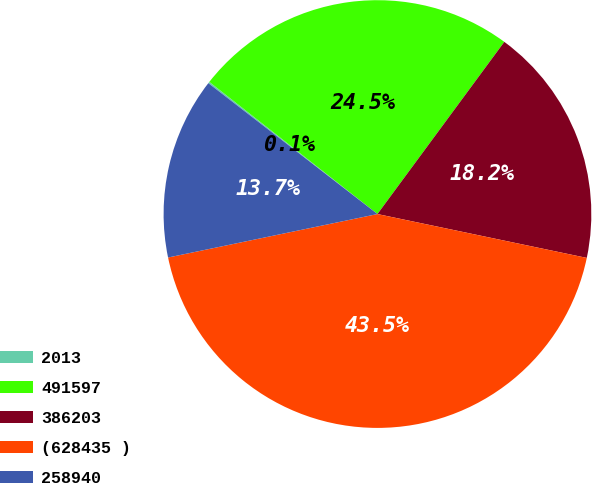Convert chart. <chart><loc_0><loc_0><loc_500><loc_500><pie_chart><fcel>2013<fcel>491597<fcel>386203<fcel>(628435 )<fcel>258940<nl><fcel>0.12%<fcel>24.5%<fcel>18.18%<fcel>43.45%<fcel>13.74%<nl></chart> 